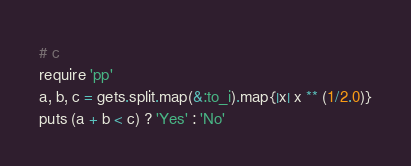Convert code to text. <code><loc_0><loc_0><loc_500><loc_500><_Ruby_># c
require 'pp'
a, b, c = gets.split.map(&:to_i).map{|x| x ** (1/2.0)}
puts (a + b < c) ? 'Yes' : 'No'



</code> 